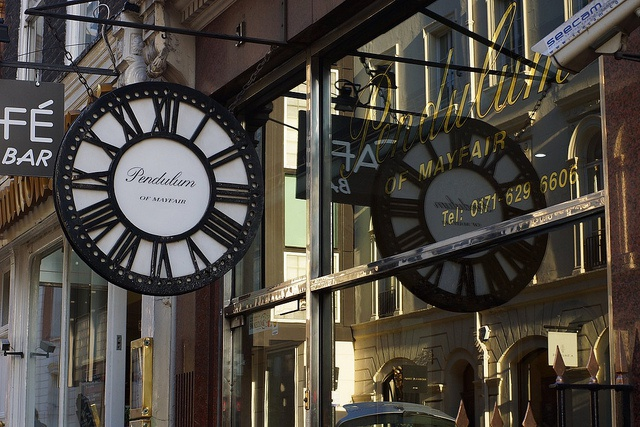Describe the objects in this image and their specific colors. I can see clock in maroon, black, darkgray, and gray tones and clock in maroon, black, purple, and darkgreen tones in this image. 